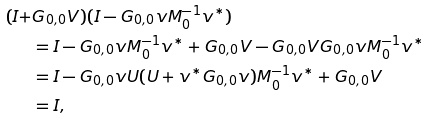<formula> <loc_0><loc_0><loc_500><loc_500>( I + & G _ { 0 , 0 } V ) ( I - G _ { 0 , 0 } v M _ { 0 } ^ { - 1 } v ^ { * } ) \\ & = I - G _ { 0 , 0 } v M _ { 0 } ^ { - 1 } v ^ { * } + G _ { 0 , 0 } V - G _ { 0 , 0 } V G _ { 0 , 0 } v M _ { 0 } ^ { - 1 } v ^ { * } \\ & = I - G _ { 0 , 0 } v U ( U + v ^ { * } G _ { 0 , 0 } v ) M _ { 0 } ^ { - 1 } v ^ { * } + G _ { 0 , 0 } V \\ & = I ,</formula> 